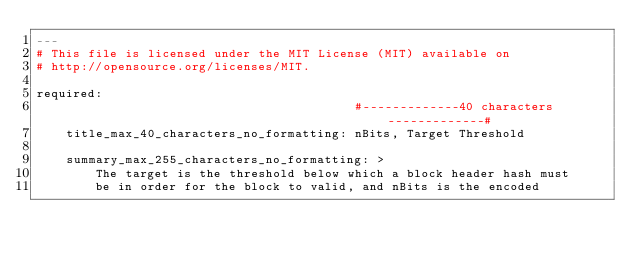Convert code to text. <code><loc_0><loc_0><loc_500><loc_500><_YAML_>---
# This file is licensed under the MIT License (MIT) available on
# http://opensource.org/licenses/MIT.

required:
                                           #-------------40 characters-------------#
    title_max_40_characters_no_formatting: nBits, Target Threshold

    summary_max_255_characters_no_formatting: >
        The target is the threshold below which a block header hash must
        be in order for the block to valid, and nBits is the encoded</code> 